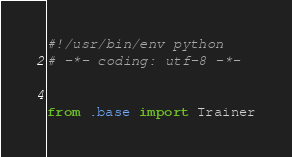Convert code to text. <code><loc_0><loc_0><loc_500><loc_500><_Python_>#!/usr/bin/env python
# -*- coding: utf-8 -*-


from .base import Trainer</code> 